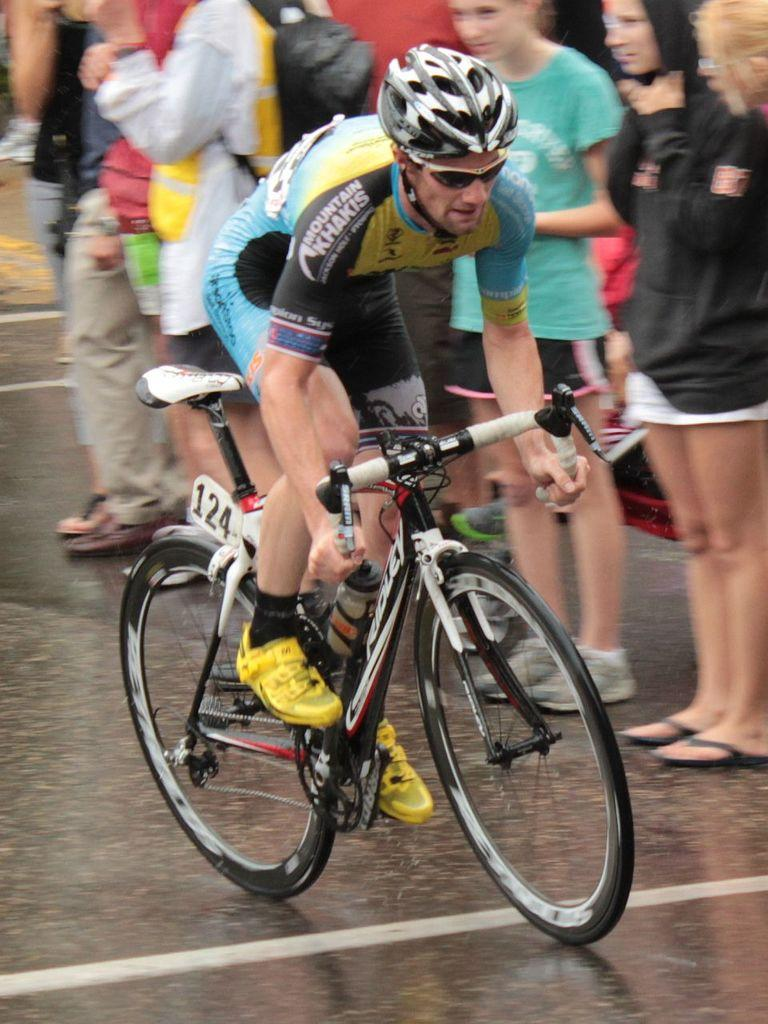What is the man in the image doing? The man is riding a bicycle in the image. What can be seen in the background of the image? There is a group of people standing in the background of the image. Where are the group of people located in the image? The group of people is standing in the road. What question is being asked by the slave in the image? There is no slave or question being asked in the image; it features a man riding a bicycle and a group of people standing in the road. 